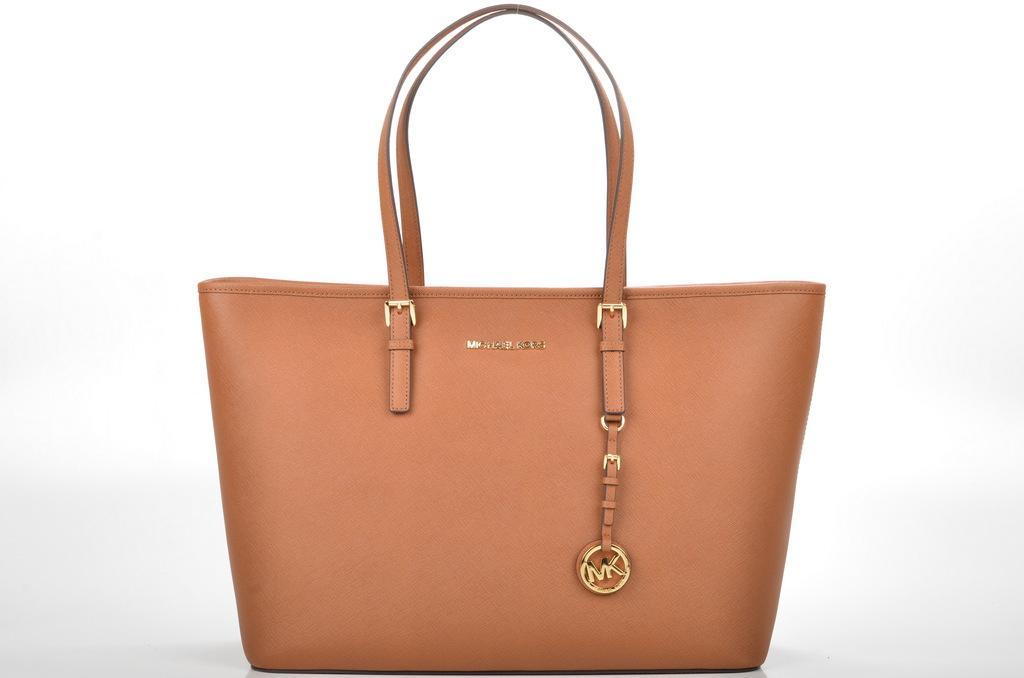Could you give a brief overview of what you see in this image? In this image I see a handbag which is of brown in color. 